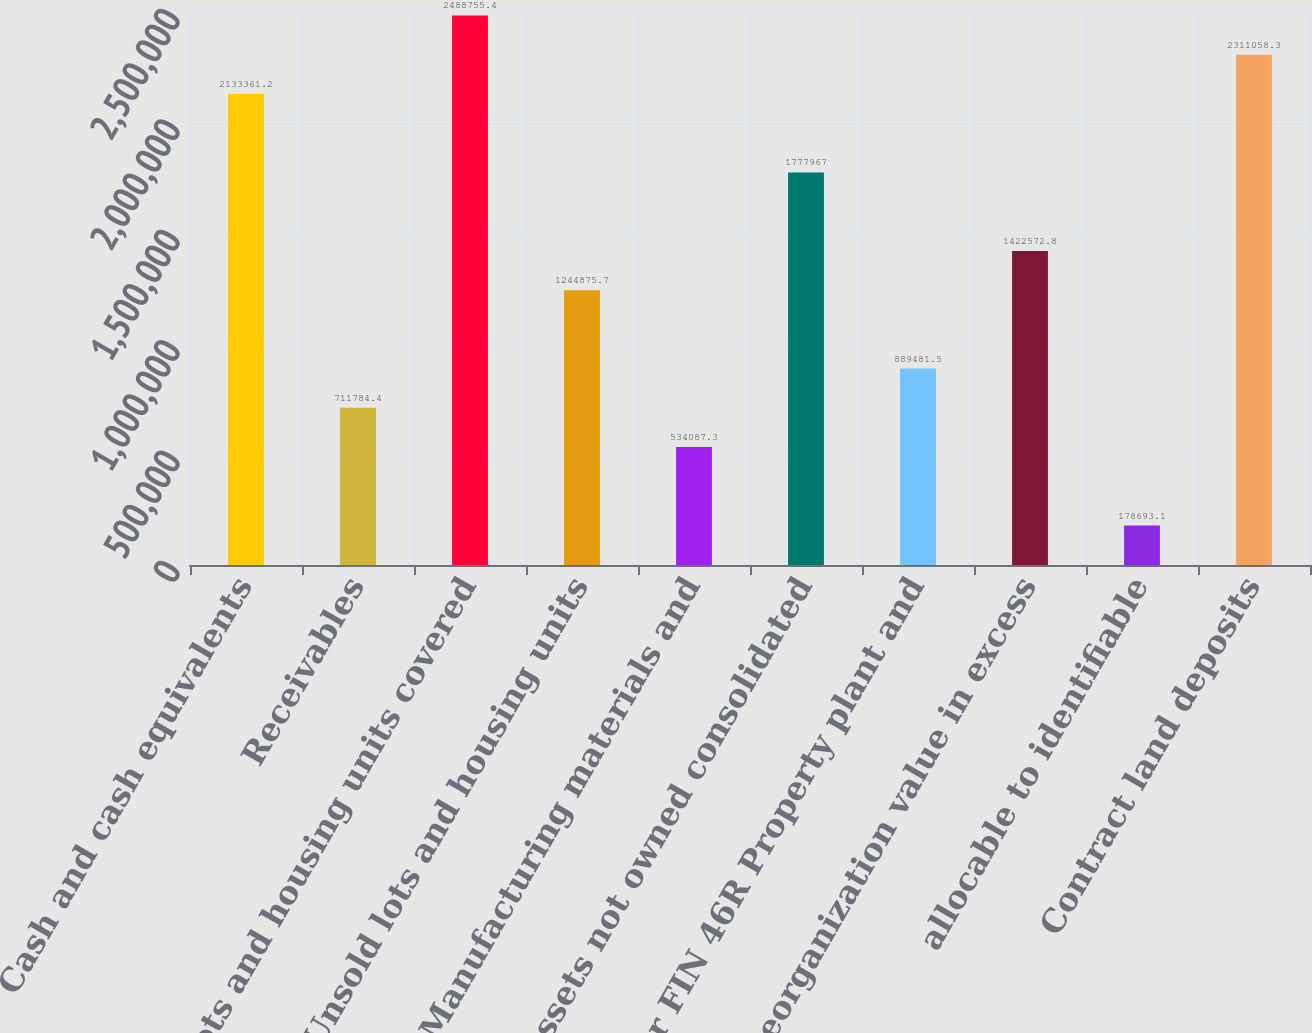Convert chart. <chart><loc_0><loc_0><loc_500><loc_500><bar_chart><fcel>Cash and cash equivalents<fcel>Receivables<fcel>Lots and housing units covered<fcel>Unsold lots and housing units<fcel>Manufacturing materials and<fcel>Assets not owned consolidated<fcel>per FIN 46R Property plant and<fcel>Reorganization value in excess<fcel>allocable to identifiable<fcel>Contract land deposits<nl><fcel>2.13336e+06<fcel>711784<fcel>2.48876e+06<fcel>1.24488e+06<fcel>534087<fcel>1.77797e+06<fcel>889482<fcel>1.42257e+06<fcel>178693<fcel>2.31106e+06<nl></chart> 